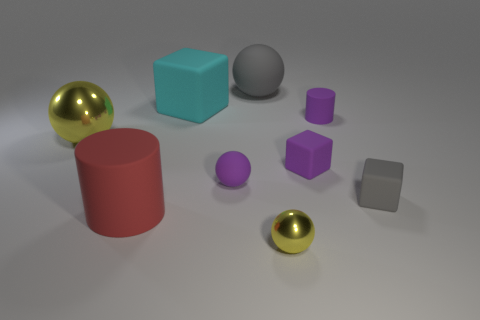There is a large cylinder that is in front of the purple rubber sphere; is its color the same as the matte sphere in front of the big matte cube?
Offer a very short reply. No. What is the size of the matte cube that is to the left of the yellow shiny thing in front of the cylinder to the left of the tiny purple sphere?
Keep it short and to the point. Large. What is the shape of the rubber thing that is both in front of the tiny purple matte ball and left of the small gray object?
Give a very brief answer. Cylinder. Is the number of large gray matte balls that are in front of the tiny purple block the same as the number of purple cubes on the left side of the cyan thing?
Your response must be concise. Yes. Is there a brown cube that has the same material as the big red thing?
Provide a short and direct response. No. Do the yellow sphere that is in front of the red thing and the purple cube have the same material?
Make the answer very short. No. How big is the object that is both behind the tiny rubber cylinder and in front of the big matte sphere?
Give a very brief answer. Large. The small matte cylinder has what color?
Give a very brief answer. Purple. What number of large yellow shiny objects are there?
Provide a short and direct response. 1. How many things are the same color as the large rubber sphere?
Offer a terse response. 1. 